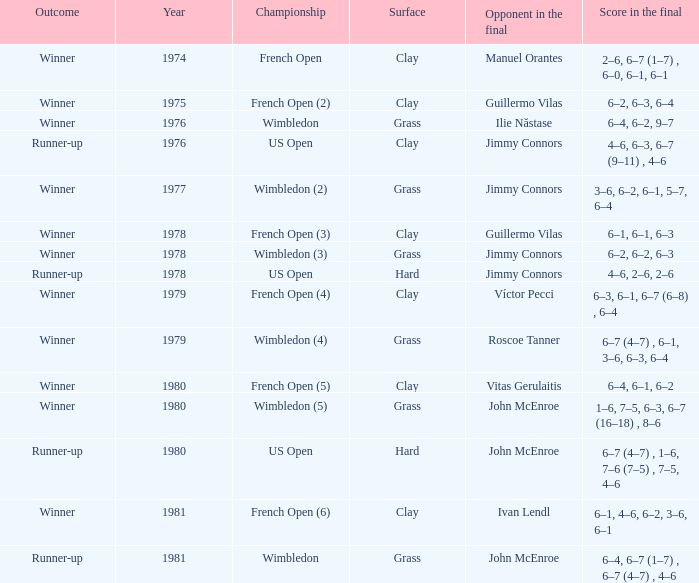What surfaces had a final match with the scores 6-4, 6-7 (1-7), 6-7 (4-7), and 4-6? Grass. Parse the table in full. {'header': ['Outcome', 'Year', 'Championship', 'Surface', 'Opponent in the final', 'Score in the final'], 'rows': [['Winner', '1974', 'French Open', 'Clay', 'Manuel Orantes', '2–6, 6–7 (1–7) , 6–0, 6–1, 6–1'], ['Winner', '1975', 'French Open (2)', 'Clay', 'Guillermo Vilas', '6–2, 6–3, 6–4'], ['Winner', '1976', 'Wimbledon', 'Grass', 'Ilie Năstase', '6–4, 6–2, 9–7'], ['Runner-up', '1976', 'US Open', 'Clay', 'Jimmy Connors', '4–6, 6–3, 6–7 (9–11) , 4–6'], ['Winner', '1977', 'Wimbledon (2)', 'Grass', 'Jimmy Connors', '3–6, 6–2, 6–1, 5–7, 6–4'], ['Winner', '1978', 'French Open (3)', 'Clay', 'Guillermo Vilas', '6–1, 6–1, 6–3'], ['Winner', '1978', 'Wimbledon (3)', 'Grass', 'Jimmy Connors', '6–2, 6–2, 6–3'], ['Runner-up', '1978', 'US Open', 'Hard', 'Jimmy Connors', '4–6, 2–6, 2–6'], ['Winner', '1979', 'French Open (4)', 'Clay', 'Víctor Pecci', '6–3, 6–1, 6–7 (6–8) , 6–4'], ['Winner', '1979', 'Wimbledon (4)', 'Grass', 'Roscoe Tanner', '6–7 (4–7) , 6–1, 3–6, 6–3, 6–4'], ['Winner', '1980', 'French Open (5)', 'Clay', 'Vitas Gerulaitis', '6–4, 6–1, 6–2'], ['Winner', '1980', 'Wimbledon (5)', 'Grass', 'John McEnroe', '1–6, 7–5, 6–3, 6–7 (16–18) , 8–6'], ['Runner-up', '1980', 'US Open', 'Hard', 'John McEnroe', '6–7 (4–7) , 1–6, 7–6 (7–5) , 7–5, 4–6'], ['Winner', '1981', 'French Open (6)', 'Clay', 'Ivan Lendl', '6–1, 4–6, 6–2, 3–6, 6–1'], ['Runner-up', '1981', 'Wimbledon', 'Grass', 'John McEnroe', '6–4, 6–7 (1–7) , 6–7 (4–7) , 4–6']]} 